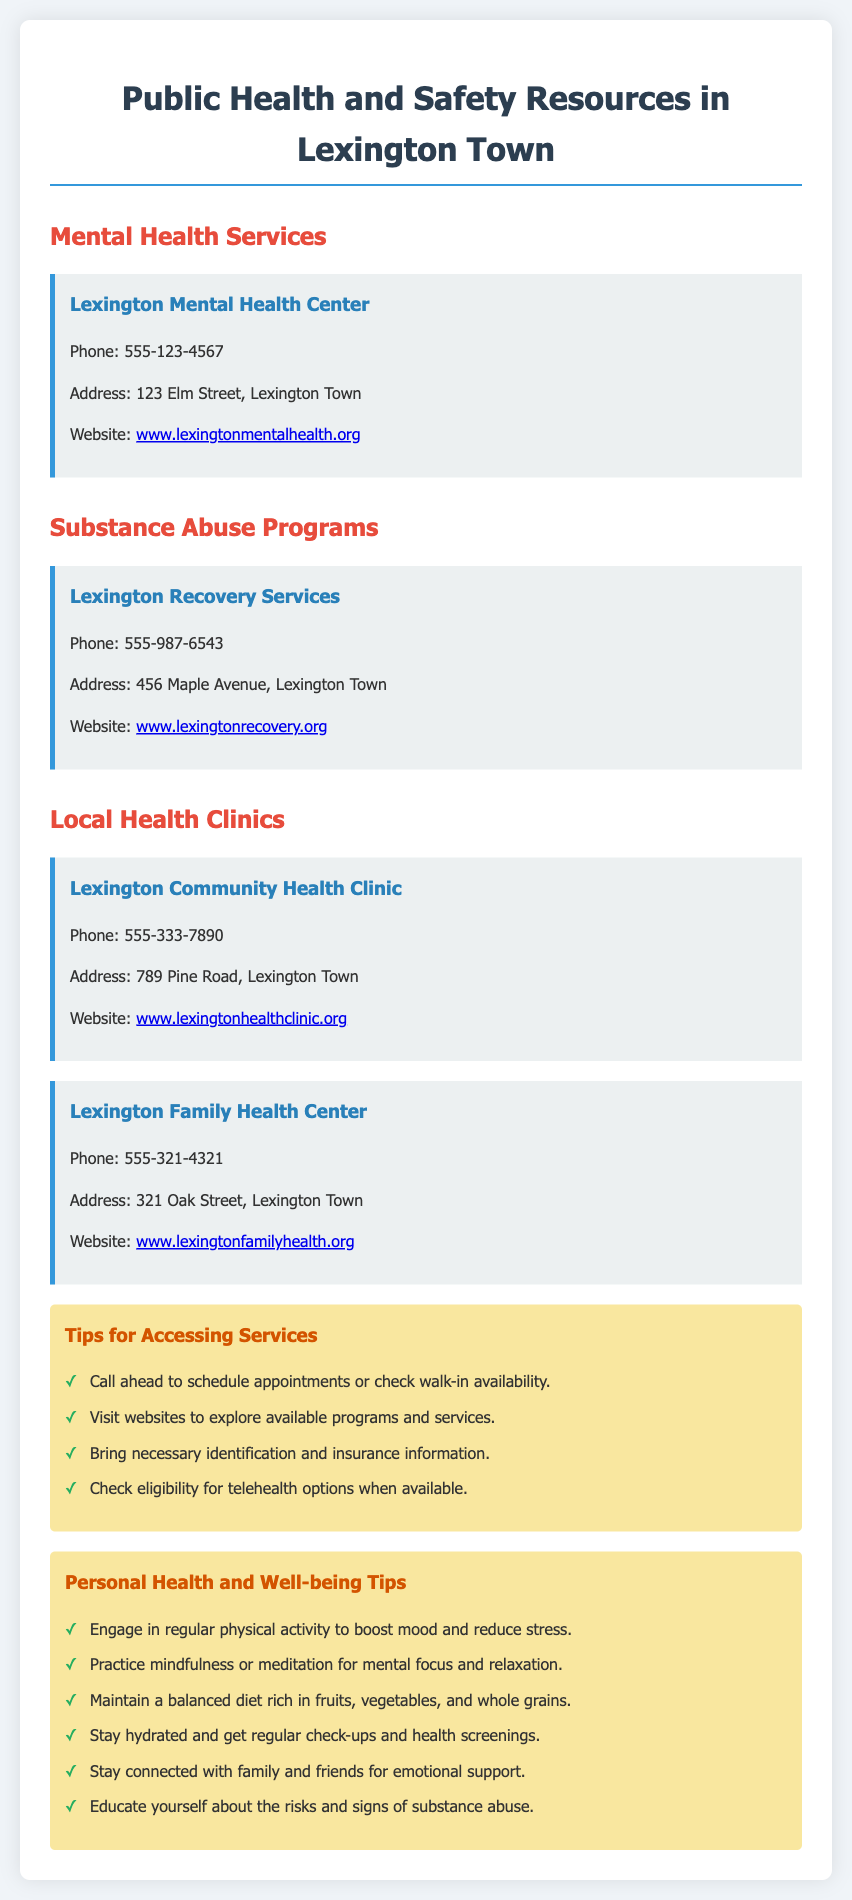What is the phone number for the Lexington Mental Health Center? The phone number is stated directly in the document for the Lexington Mental Health Center.
Answer: 555-123-4567 What is the address of Lexington Recovery Services? The address is given in the document under the section for Substance Abuse Programs.
Answer: 456 Maple Avenue, Lexington Town Which clinic specializes in family health? The document lists two local health clinics, and one specifies family health in its name.
Answer: Lexington Family Health Center How many local health clinics are mentioned in the document? The document mentions two separate health clinics under the Local Health Clinics section.
Answer: 2 What is one tip for accessing health services? The document provides a list of tips and one of them addresses scheduling appointments.
Answer: Call ahead to schedule appointments or check walk-in availability What is a personal health tip regarding diet? The document includes tips for maintaining personal health, specifically mentioning dietary habits.
Answer: Maintain a balanced diet rich in fruits, vegetables, and whole grains Where can I find more information about Lexington Community Health Clinic? The document provides a web address where you can explore more about the clinic.
Answer: www.lexingtonhealthclinic.org What kind of program does Lexington Recovery Services offer? The document specifies the type of service provided by Lexington Recovery Services, revealing its focus.
Answer: Substance abuse programs 